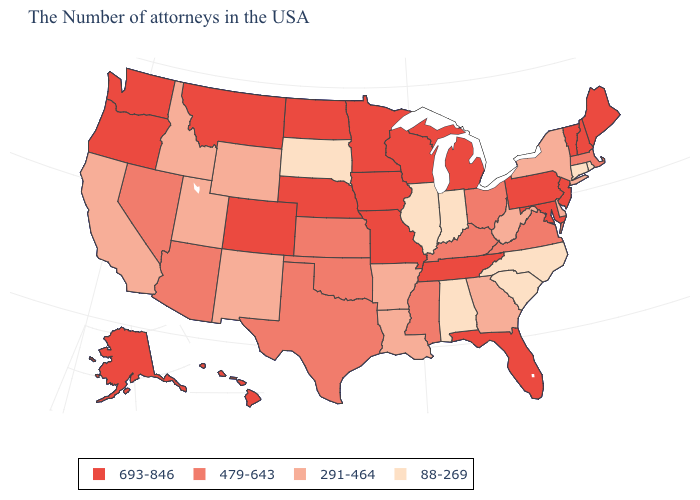What is the lowest value in states that border Pennsylvania?
Write a very short answer. 291-464. How many symbols are there in the legend?
Give a very brief answer. 4. What is the value of Oklahoma?
Quick response, please. 479-643. What is the value of Montana?
Give a very brief answer. 693-846. Does Arizona have the lowest value in the USA?
Answer briefly. No. Name the states that have a value in the range 88-269?
Short answer required. Rhode Island, Connecticut, North Carolina, South Carolina, Indiana, Alabama, Illinois, South Dakota. Which states have the highest value in the USA?
Short answer required. Maine, New Hampshire, Vermont, New Jersey, Maryland, Pennsylvania, Florida, Michigan, Tennessee, Wisconsin, Missouri, Minnesota, Iowa, Nebraska, North Dakota, Colorado, Montana, Washington, Oregon, Alaska, Hawaii. Does New Hampshire have a lower value than Wisconsin?
Write a very short answer. No. What is the value of Michigan?
Answer briefly. 693-846. What is the highest value in the USA?
Write a very short answer. 693-846. Name the states that have a value in the range 88-269?
Be succinct. Rhode Island, Connecticut, North Carolina, South Carolina, Indiana, Alabama, Illinois, South Dakota. What is the value of Arizona?
Give a very brief answer. 479-643. Does the first symbol in the legend represent the smallest category?
Be succinct. No. What is the value of New Jersey?
Quick response, please. 693-846. 